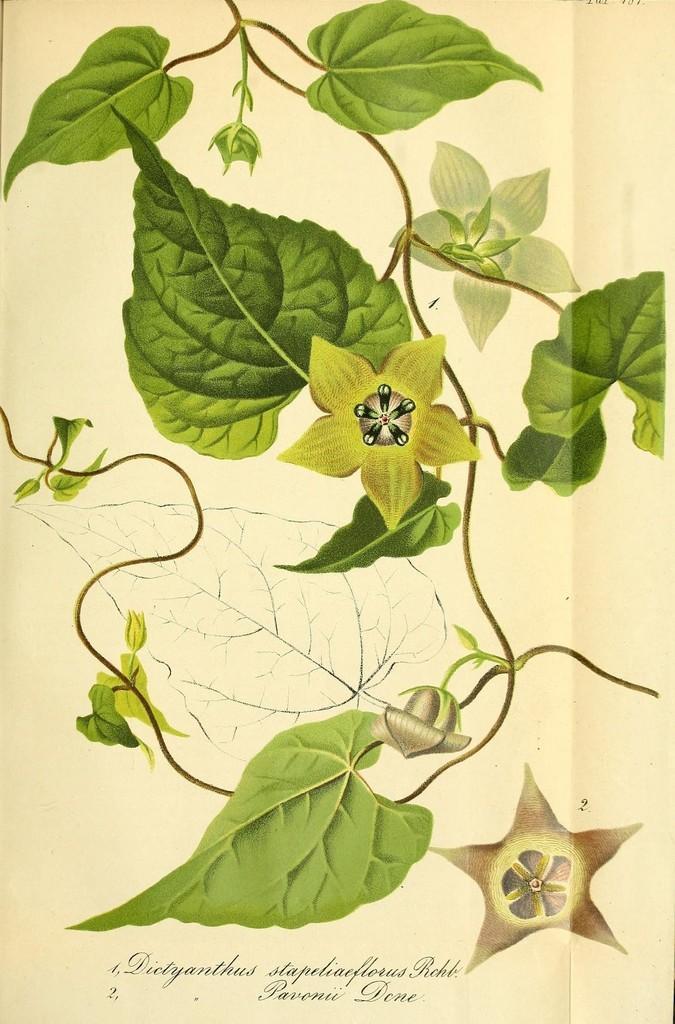Could you give a brief overview of what you see in this image? In this image there is a paper on which there are leaves,flowers and there is some text at the bottom of the image. 